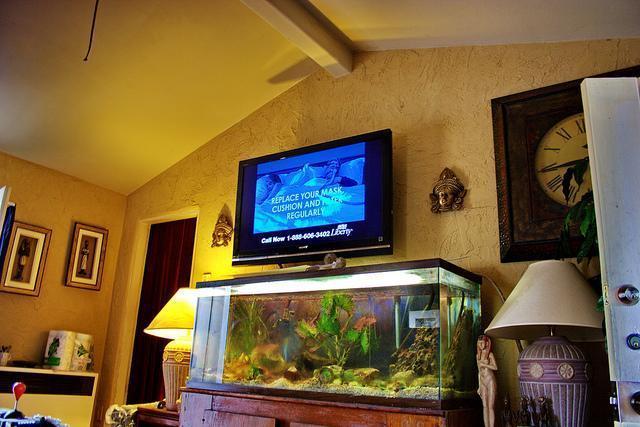How many televisions are on?
Give a very brief answer. 1. 